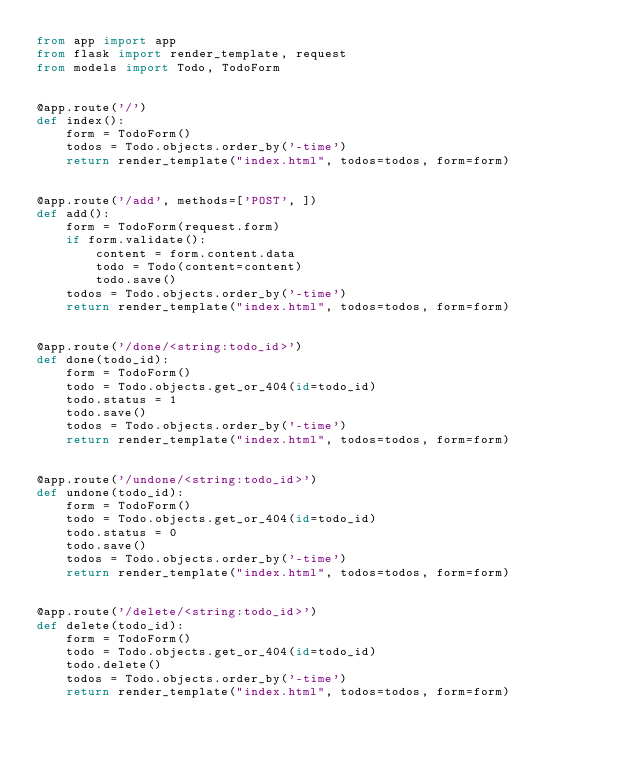Convert code to text. <code><loc_0><loc_0><loc_500><loc_500><_Python_>from app import app
from flask import render_template, request
from models import Todo, TodoForm


@app.route('/')
def index():
    form = TodoForm()
    todos = Todo.objects.order_by('-time')
    return render_template("index.html", todos=todos, form=form)


@app.route('/add', methods=['POST', ])
def add():
    form = TodoForm(request.form)
    if form.validate():
        content = form.content.data
        todo = Todo(content=content)
        todo.save()
    todos = Todo.objects.order_by('-time')
    return render_template("index.html", todos=todos, form=form)


@app.route('/done/<string:todo_id>')
def done(todo_id):
    form = TodoForm()
    todo = Todo.objects.get_or_404(id=todo_id)
    todo.status = 1
    todo.save()
    todos = Todo.objects.order_by('-time')
    return render_template("index.html", todos=todos, form=form)


@app.route('/undone/<string:todo_id>')
def undone(todo_id):
    form = TodoForm()
    todo = Todo.objects.get_or_404(id=todo_id)
    todo.status = 0
    todo.save()
    todos = Todo.objects.order_by('-time')
    return render_template("index.html", todos=todos, form=form)


@app.route('/delete/<string:todo_id>')
def delete(todo_id):
    form = TodoForm()
    todo = Todo.objects.get_or_404(id=todo_id)
    todo.delete()
    todos = Todo.objects.order_by('-time')
    return render_template("index.html", todos=todos, form=form)</code> 